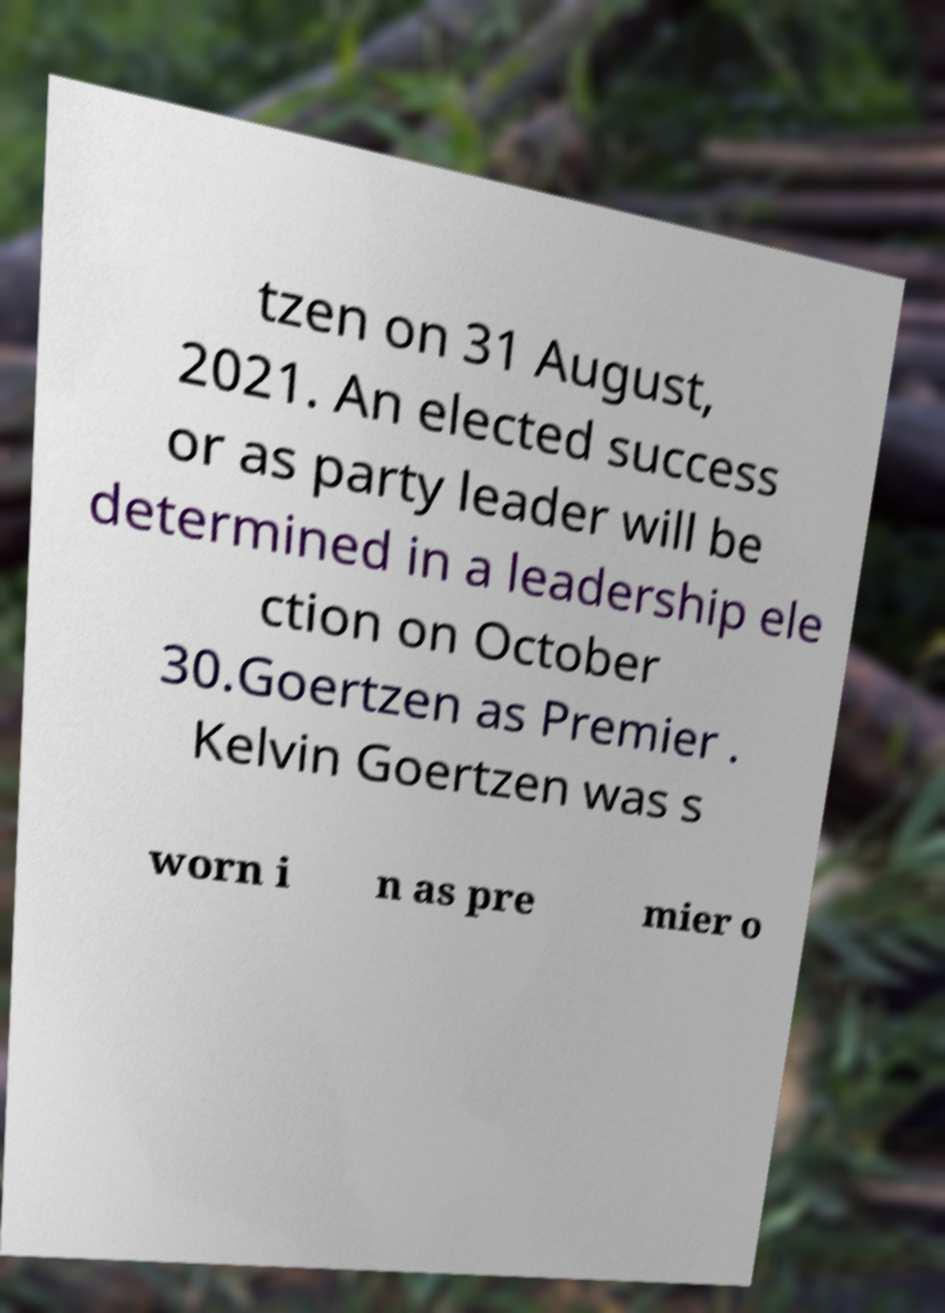Can you accurately transcribe the text from the provided image for me? tzen on 31 August, 2021. An elected success or as party leader will be determined in a leadership ele ction on October 30.Goertzen as Premier . Kelvin Goertzen was s worn i n as pre mier o 